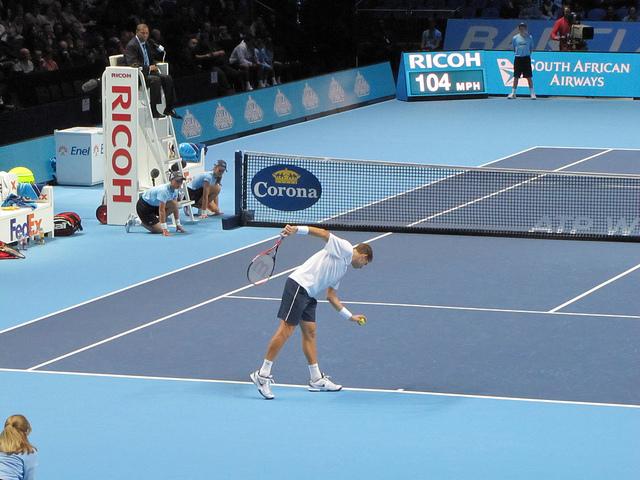Extract all visible text content from this image. RICOH Enei RICOH Corona A AIRWAYS NKOH MPH 104 AFRICAN ATP E X FedEx 